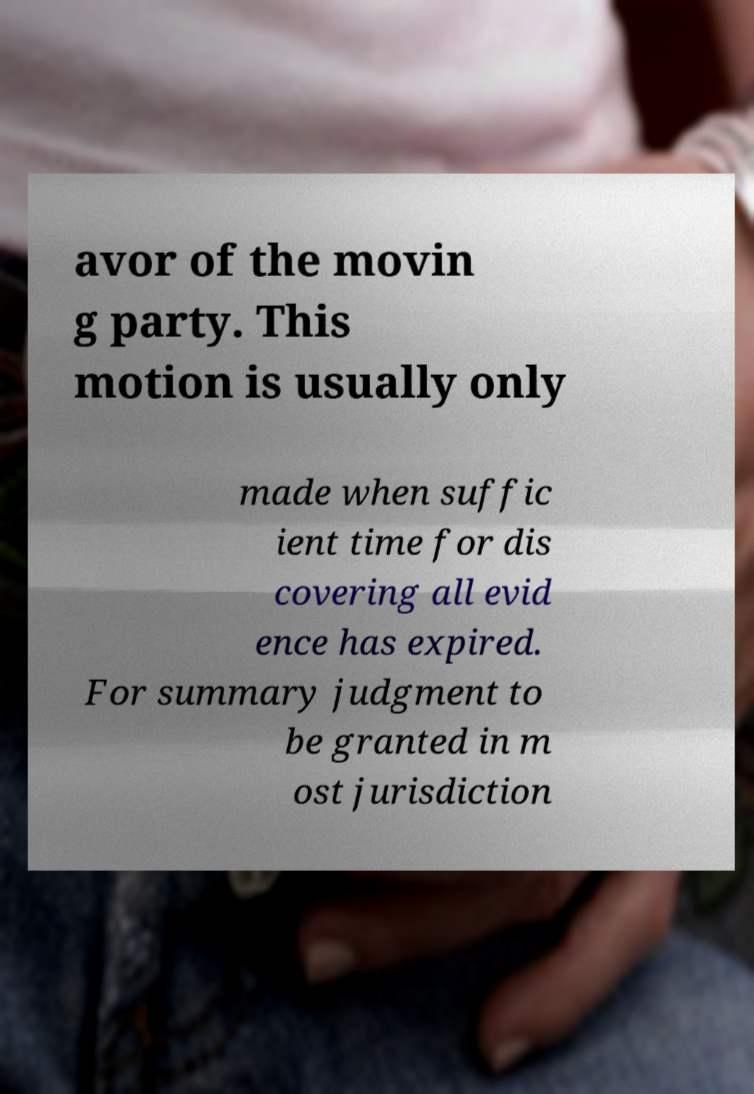Can you read and provide the text displayed in the image?This photo seems to have some interesting text. Can you extract and type it out for me? avor of the movin g party. This motion is usually only made when suffic ient time for dis covering all evid ence has expired. For summary judgment to be granted in m ost jurisdiction 